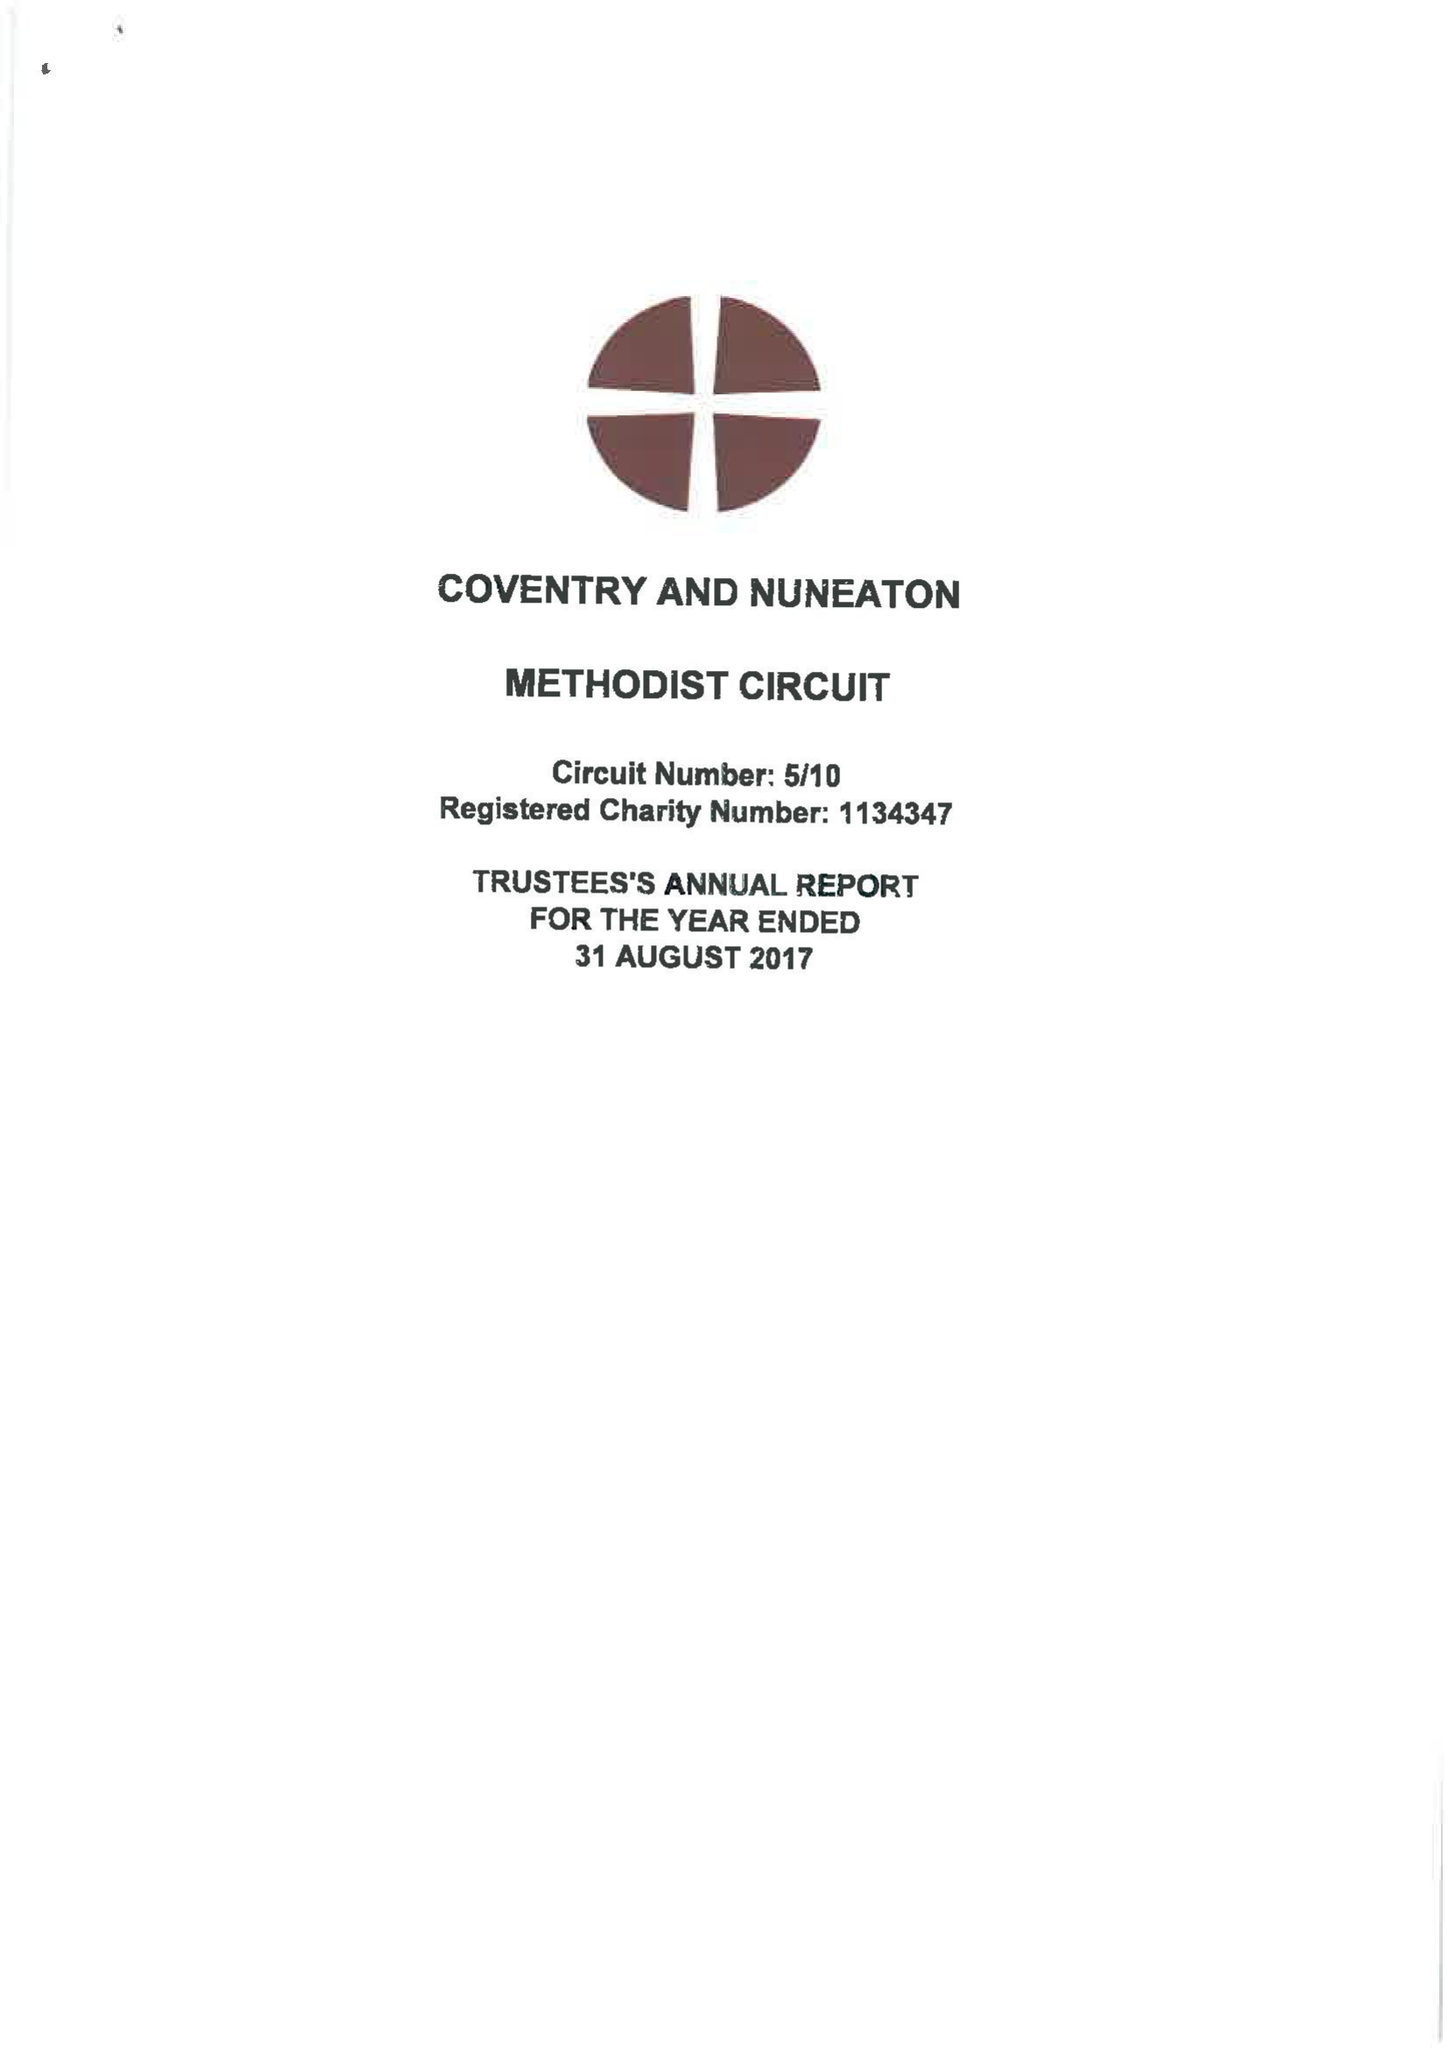What is the value for the address__post_town?
Answer the question using a single word or phrase. COVENTRY 